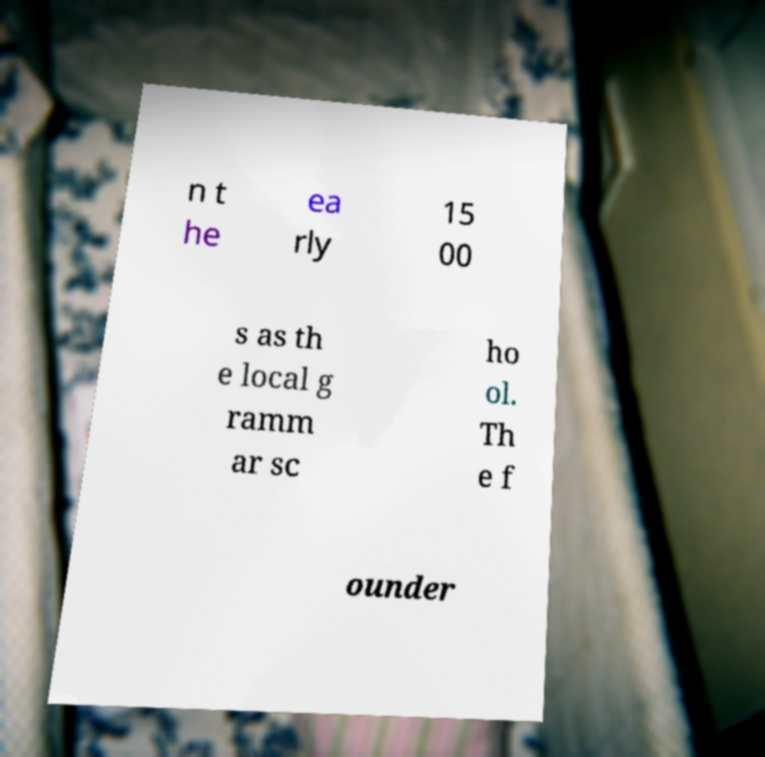I need the written content from this picture converted into text. Can you do that? n t he ea rly 15 00 s as th e local g ramm ar sc ho ol. Th e f ounder 